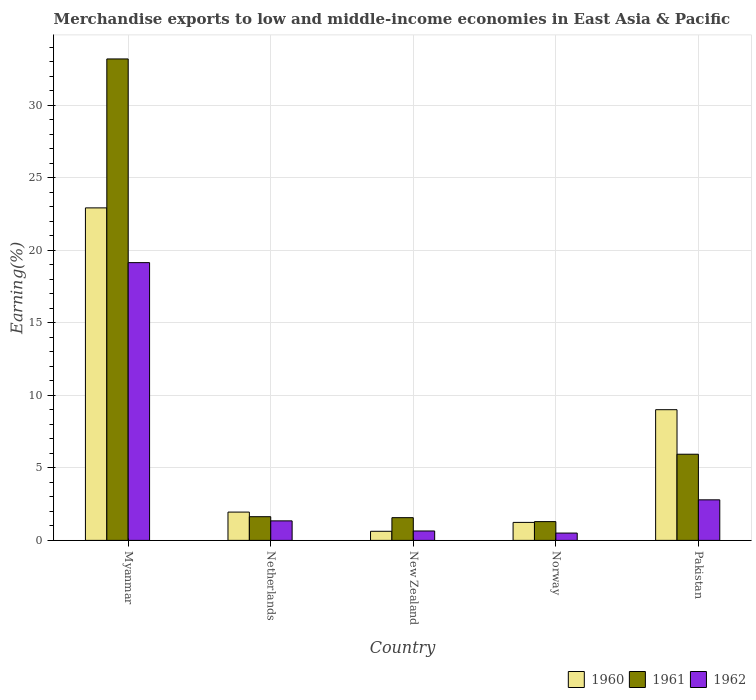How many groups of bars are there?
Ensure brevity in your answer.  5. Are the number of bars per tick equal to the number of legend labels?
Provide a succinct answer. Yes. Are the number of bars on each tick of the X-axis equal?
Offer a terse response. Yes. How many bars are there on the 4th tick from the left?
Your answer should be compact. 3. What is the label of the 2nd group of bars from the left?
Your answer should be very brief. Netherlands. In how many cases, is the number of bars for a given country not equal to the number of legend labels?
Offer a terse response. 0. What is the percentage of amount earned from merchandise exports in 1962 in New Zealand?
Offer a very short reply. 0.65. Across all countries, what is the maximum percentage of amount earned from merchandise exports in 1962?
Your answer should be compact. 19.15. Across all countries, what is the minimum percentage of amount earned from merchandise exports in 1962?
Provide a succinct answer. 0.5. In which country was the percentage of amount earned from merchandise exports in 1962 maximum?
Your response must be concise. Myanmar. In which country was the percentage of amount earned from merchandise exports in 1961 minimum?
Keep it short and to the point. Norway. What is the total percentage of amount earned from merchandise exports in 1962 in the graph?
Your answer should be very brief. 24.44. What is the difference between the percentage of amount earned from merchandise exports in 1960 in Myanmar and that in Pakistan?
Ensure brevity in your answer.  13.91. What is the difference between the percentage of amount earned from merchandise exports in 1962 in Myanmar and the percentage of amount earned from merchandise exports in 1960 in New Zealand?
Your answer should be very brief. 18.52. What is the average percentage of amount earned from merchandise exports in 1962 per country?
Keep it short and to the point. 4.89. What is the difference between the percentage of amount earned from merchandise exports of/in 1961 and percentage of amount earned from merchandise exports of/in 1960 in New Zealand?
Offer a terse response. 0.94. What is the ratio of the percentage of amount earned from merchandise exports in 1960 in New Zealand to that in Norway?
Provide a succinct answer. 0.51. Is the percentage of amount earned from merchandise exports in 1961 in Myanmar less than that in Pakistan?
Keep it short and to the point. No. Is the difference between the percentage of amount earned from merchandise exports in 1961 in Netherlands and New Zealand greater than the difference between the percentage of amount earned from merchandise exports in 1960 in Netherlands and New Zealand?
Your answer should be compact. No. What is the difference between the highest and the second highest percentage of amount earned from merchandise exports in 1961?
Your response must be concise. 27.25. What is the difference between the highest and the lowest percentage of amount earned from merchandise exports in 1962?
Your answer should be very brief. 18.64. Is the sum of the percentage of amount earned from merchandise exports in 1961 in Netherlands and Pakistan greater than the maximum percentage of amount earned from merchandise exports in 1962 across all countries?
Offer a very short reply. No. What does the 1st bar from the right in Pakistan represents?
Offer a very short reply. 1962. Is it the case that in every country, the sum of the percentage of amount earned from merchandise exports in 1961 and percentage of amount earned from merchandise exports in 1962 is greater than the percentage of amount earned from merchandise exports in 1960?
Make the answer very short. No. Are all the bars in the graph horizontal?
Give a very brief answer. No. Are the values on the major ticks of Y-axis written in scientific E-notation?
Give a very brief answer. No. Does the graph contain grids?
Offer a very short reply. Yes. How many legend labels are there?
Give a very brief answer. 3. How are the legend labels stacked?
Offer a very short reply. Horizontal. What is the title of the graph?
Provide a short and direct response. Merchandise exports to low and middle-income economies in East Asia & Pacific. What is the label or title of the Y-axis?
Make the answer very short. Earning(%). What is the Earning(%) of 1960 in Myanmar?
Your answer should be compact. 22.92. What is the Earning(%) in 1961 in Myanmar?
Offer a terse response. 33.19. What is the Earning(%) in 1962 in Myanmar?
Your response must be concise. 19.15. What is the Earning(%) in 1960 in Netherlands?
Keep it short and to the point. 1.95. What is the Earning(%) in 1961 in Netherlands?
Provide a short and direct response. 1.63. What is the Earning(%) of 1962 in Netherlands?
Give a very brief answer. 1.35. What is the Earning(%) in 1960 in New Zealand?
Provide a succinct answer. 0.63. What is the Earning(%) in 1961 in New Zealand?
Your response must be concise. 1.57. What is the Earning(%) in 1962 in New Zealand?
Ensure brevity in your answer.  0.65. What is the Earning(%) of 1960 in Norway?
Provide a short and direct response. 1.24. What is the Earning(%) in 1961 in Norway?
Your answer should be compact. 1.29. What is the Earning(%) in 1962 in Norway?
Offer a terse response. 0.5. What is the Earning(%) of 1960 in Pakistan?
Offer a terse response. 9.01. What is the Earning(%) in 1961 in Pakistan?
Your response must be concise. 5.94. What is the Earning(%) in 1962 in Pakistan?
Make the answer very short. 2.8. Across all countries, what is the maximum Earning(%) of 1960?
Your answer should be very brief. 22.92. Across all countries, what is the maximum Earning(%) in 1961?
Ensure brevity in your answer.  33.19. Across all countries, what is the maximum Earning(%) in 1962?
Provide a succinct answer. 19.15. Across all countries, what is the minimum Earning(%) of 1960?
Give a very brief answer. 0.63. Across all countries, what is the minimum Earning(%) in 1961?
Offer a terse response. 1.29. Across all countries, what is the minimum Earning(%) of 1962?
Ensure brevity in your answer.  0.5. What is the total Earning(%) in 1960 in the graph?
Your answer should be very brief. 35.75. What is the total Earning(%) of 1961 in the graph?
Provide a short and direct response. 43.63. What is the total Earning(%) of 1962 in the graph?
Your answer should be compact. 24.44. What is the difference between the Earning(%) in 1960 in Myanmar and that in Netherlands?
Keep it short and to the point. 20.97. What is the difference between the Earning(%) of 1961 in Myanmar and that in Netherlands?
Keep it short and to the point. 31.56. What is the difference between the Earning(%) in 1962 in Myanmar and that in Netherlands?
Provide a short and direct response. 17.8. What is the difference between the Earning(%) of 1960 in Myanmar and that in New Zealand?
Provide a succinct answer. 22.3. What is the difference between the Earning(%) in 1961 in Myanmar and that in New Zealand?
Provide a succinct answer. 31.62. What is the difference between the Earning(%) in 1962 in Myanmar and that in New Zealand?
Keep it short and to the point. 18.5. What is the difference between the Earning(%) in 1960 in Myanmar and that in Norway?
Offer a terse response. 21.68. What is the difference between the Earning(%) in 1961 in Myanmar and that in Norway?
Your answer should be compact. 31.9. What is the difference between the Earning(%) of 1962 in Myanmar and that in Norway?
Give a very brief answer. 18.64. What is the difference between the Earning(%) in 1960 in Myanmar and that in Pakistan?
Provide a succinct answer. 13.91. What is the difference between the Earning(%) of 1961 in Myanmar and that in Pakistan?
Keep it short and to the point. 27.25. What is the difference between the Earning(%) of 1962 in Myanmar and that in Pakistan?
Your answer should be compact. 16.35. What is the difference between the Earning(%) of 1960 in Netherlands and that in New Zealand?
Keep it short and to the point. 1.32. What is the difference between the Earning(%) in 1961 in Netherlands and that in New Zealand?
Provide a succinct answer. 0.07. What is the difference between the Earning(%) in 1962 in Netherlands and that in New Zealand?
Your response must be concise. 0.7. What is the difference between the Earning(%) in 1960 in Netherlands and that in Norway?
Your answer should be very brief. 0.71. What is the difference between the Earning(%) of 1961 in Netherlands and that in Norway?
Your answer should be very brief. 0.34. What is the difference between the Earning(%) in 1962 in Netherlands and that in Norway?
Give a very brief answer. 0.84. What is the difference between the Earning(%) of 1960 in Netherlands and that in Pakistan?
Offer a very short reply. -7.06. What is the difference between the Earning(%) of 1961 in Netherlands and that in Pakistan?
Keep it short and to the point. -4.31. What is the difference between the Earning(%) of 1962 in Netherlands and that in Pakistan?
Provide a short and direct response. -1.45. What is the difference between the Earning(%) in 1960 in New Zealand and that in Norway?
Give a very brief answer. -0.61. What is the difference between the Earning(%) in 1961 in New Zealand and that in Norway?
Your response must be concise. 0.27. What is the difference between the Earning(%) of 1962 in New Zealand and that in Norway?
Ensure brevity in your answer.  0.14. What is the difference between the Earning(%) in 1960 in New Zealand and that in Pakistan?
Provide a short and direct response. -8.38. What is the difference between the Earning(%) of 1961 in New Zealand and that in Pakistan?
Provide a succinct answer. -4.37. What is the difference between the Earning(%) of 1962 in New Zealand and that in Pakistan?
Make the answer very short. -2.15. What is the difference between the Earning(%) in 1960 in Norway and that in Pakistan?
Keep it short and to the point. -7.77. What is the difference between the Earning(%) of 1961 in Norway and that in Pakistan?
Provide a succinct answer. -4.65. What is the difference between the Earning(%) of 1962 in Norway and that in Pakistan?
Offer a terse response. -2.29. What is the difference between the Earning(%) in 1960 in Myanmar and the Earning(%) in 1961 in Netherlands?
Provide a short and direct response. 21.29. What is the difference between the Earning(%) of 1960 in Myanmar and the Earning(%) of 1962 in Netherlands?
Ensure brevity in your answer.  21.58. What is the difference between the Earning(%) in 1961 in Myanmar and the Earning(%) in 1962 in Netherlands?
Provide a succinct answer. 31.85. What is the difference between the Earning(%) in 1960 in Myanmar and the Earning(%) in 1961 in New Zealand?
Make the answer very short. 21.36. What is the difference between the Earning(%) in 1960 in Myanmar and the Earning(%) in 1962 in New Zealand?
Offer a very short reply. 22.27. What is the difference between the Earning(%) of 1961 in Myanmar and the Earning(%) of 1962 in New Zealand?
Offer a very short reply. 32.54. What is the difference between the Earning(%) in 1960 in Myanmar and the Earning(%) in 1961 in Norway?
Ensure brevity in your answer.  21.63. What is the difference between the Earning(%) of 1960 in Myanmar and the Earning(%) of 1962 in Norway?
Keep it short and to the point. 22.42. What is the difference between the Earning(%) in 1961 in Myanmar and the Earning(%) in 1962 in Norway?
Your answer should be very brief. 32.69. What is the difference between the Earning(%) of 1960 in Myanmar and the Earning(%) of 1961 in Pakistan?
Provide a short and direct response. 16.98. What is the difference between the Earning(%) of 1960 in Myanmar and the Earning(%) of 1962 in Pakistan?
Provide a short and direct response. 20.13. What is the difference between the Earning(%) in 1961 in Myanmar and the Earning(%) in 1962 in Pakistan?
Give a very brief answer. 30.39. What is the difference between the Earning(%) of 1960 in Netherlands and the Earning(%) of 1961 in New Zealand?
Ensure brevity in your answer.  0.39. What is the difference between the Earning(%) of 1960 in Netherlands and the Earning(%) of 1962 in New Zealand?
Provide a succinct answer. 1.3. What is the difference between the Earning(%) of 1961 in Netherlands and the Earning(%) of 1962 in New Zealand?
Keep it short and to the point. 0.98. What is the difference between the Earning(%) in 1960 in Netherlands and the Earning(%) in 1961 in Norway?
Your response must be concise. 0.66. What is the difference between the Earning(%) of 1960 in Netherlands and the Earning(%) of 1962 in Norway?
Offer a very short reply. 1.45. What is the difference between the Earning(%) in 1961 in Netherlands and the Earning(%) in 1962 in Norway?
Provide a succinct answer. 1.13. What is the difference between the Earning(%) of 1960 in Netherlands and the Earning(%) of 1961 in Pakistan?
Your answer should be very brief. -3.99. What is the difference between the Earning(%) in 1960 in Netherlands and the Earning(%) in 1962 in Pakistan?
Offer a terse response. -0.84. What is the difference between the Earning(%) of 1961 in Netherlands and the Earning(%) of 1962 in Pakistan?
Make the answer very short. -1.16. What is the difference between the Earning(%) of 1960 in New Zealand and the Earning(%) of 1961 in Norway?
Provide a short and direct response. -0.67. What is the difference between the Earning(%) in 1960 in New Zealand and the Earning(%) in 1962 in Norway?
Give a very brief answer. 0.12. What is the difference between the Earning(%) in 1961 in New Zealand and the Earning(%) in 1962 in Norway?
Provide a succinct answer. 1.06. What is the difference between the Earning(%) in 1960 in New Zealand and the Earning(%) in 1961 in Pakistan?
Offer a terse response. -5.31. What is the difference between the Earning(%) of 1960 in New Zealand and the Earning(%) of 1962 in Pakistan?
Keep it short and to the point. -2.17. What is the difference between the Earning(%) in 1961 in New Zealand and the Earning(%) in 1962 in Pakistan?
Ensure brevity in your answer.  -1.23. What is the difference between the Earning(%) in 1960 in Norway and the Earning(%) in 1962 in Pakistan?
Keep it short and to the point. -1.56. What is the difference between the Earning(%) in 1961 in Norway and the Earning(%) in 1962 in Pakistan?
Provide a succinct answer. -1.5. What is the average Earning(%) in 1960 per country?
Offer a terse response. 7.15. What is the average Earning(%) in 1961 per country?
Ensure brevity in your answer.  8.73. What is the average Earning(%) of 1962 per country?
Make the answer very short. 4.89. What is the difference between the Earning(%) in 1960 and Earning(%) in 1961 in Myanmar?
Your answer should be compact. -10.27. What is the difference between the Earning(%) in 1960 and Earning(%) in 1962 in Myanmar?
Make the answer very short. 3.78. What is the difference between the Earning(%) in 1961 and Earning(%) in 1962 in Myanmar?
Provide a short and direct response. 14.04. What is the difference between the Earning(%) in 1960 and Earning(%) in 1961 in Netherlands?
Make the answer very short. 0.32. What is the difference between the Earning(%) of 1960 and Earning(%) of 1962 in Netherlands?
Make the answer very short. 0.61. What is the difference between the Earning(%) of 1961 and Earning(%) of 1962 in Netherlands?
Provide a succinct answer. 0.29. What is the difference between the Earning(%) of 1960 and Earning(%) of 1961 in New Zealand?
Offer a very short reply. -0.94. What is the difference between the Earning(%) of 1960 and Earning(%) of 1962 in New Zealand?
Provide a short and direct response. -0.02. What is the difference between the Earning(%) in 1961 and Earning(%) in 1962 in New Zealand?
Provide a succinct answer. 0.92. What is the difference between the Earning(%) of 1960 and Earning(%) of 1961 in Norway?
Make the answer very short. -0.05. What is the difference between the Earning(%) of 1960 and Earning(%) of 1962 in Norway?
Make the answer very short. 0.74. What is the difference between the Earning(%) of 1961 and Earning(%) of 1962 in Norway?
Provide a succinct answer. 0.79. What is the difference between the Earning(%) in 1960 and Earning(%) in 1961 in Pakistan?
Ensure brevity in your answer.  3.07. What is the difference between the Earning(%) in 1960 and Earning(%) in 1962 in Pakistan?
Make the answer very short. 6.21. What is the difference between the Earning(%) in 1961 and Earning(%) in 1962 in Pakistan?
Offer a terse response. 3.14. What is the ratio of the Earning(%) of 1960 in Myanmar to that in Netherlands?
Offer a very short reply. 11.75. What is the ratio of the Earning(%) in 1961 in Myanmar to that in Netherlands?
Offer a very short reply. 20.31. What is the ratio of the Earning(%) in 1962 in Myanmar to that in Netherlands?
Make the answer very short. 14.23. What is the ratio of the Earning(%) in 1960 in Myanmar to that in New Zealand?
Ensure brevity in your answer.  36.54. What is the ratio of the Earning(%) of 1961 in Myanmar to that in New Zealand?
Offer a terse response. 21.19. What is the ratio of the Earning(%) in 1962 in Myanmar to that in New Zealand?
Make the answer very short. 29.51. What is the ratio of the Earning(%) of 1960 in Myanmar to that in Norway?
Provide a short and direct response. 18.48. What is the ratio of the Earning(%) in 1961 in Myanmar to that in Norway?
Your answer should be compact. 25.65. What is the ratio of the Earning(%) of 1962 in Myanmar to that in Norway?
Your answer should be compact. 37.92. What is the ratio of the Earning(%) of 1960 in Myanmar to that in Pakistan?
Your answer should be compact. 2.54. What is the ratio of the Earning(%) of 1961 in Myanmar to that in Pakistan?
Your answer should be very brief. 5.59. What is the ratio of the Earning(%) of 1962 in Myanmar to that in Pakistan?
Make the answer very short. 6.85. What is the ratio of the Earning(%) in 1960 in Netherlands to that in New Zealand?
Ensure brevity in your answer.  3.11. What is the ratio of the Earning(%) in 1961 in Netherlands to that in New Zealand?
Provide a succinct answer. 1.04. What is the ratio of the Earning(%) of 1962 in Netherlands to that in New Zealand?
Give a very brief answer. 2.07. What is the ratio of the Earning(%) of 1960 in Netherlands to that in Norway?
Give a very brief answer. 1.57. What is the ratio of the Earning(%) in 1961 in Netherlands to that in Norway?
Your answer should be compact. 1.26. What is the ratio of the Earning(%) of 1962 in Netherlands to that in Norway?
Provide a succinct answer. 2.67. What is the ratio of the Earning(%) in 1960 in Netherlands to that in Pakistan?
Offer a very short reply. 0.22. What is the ratio of the Earning(%) in 1961 in Netherlands to that in Pakistan?
Your response must be concise. 0.28. What is the ratio of the Earning(%) of 1962 in Netherlands to that in Pakistan?
Ensure brevity in your answer.  0.48. What is the ratio of the Earning(%) in 1960 in New Zealand to that in Norway?
Provide a succinct answer. 0.51. What is the ratio of the Earning(%) of 1961 in New Zealand to that in Norway?
Your answer should be very brief. 1.21. What is the ratio of the Earning(%) of 1962 in New Zealand to that in Norway?
Provide a succinct answer. 1.29. What is the ratio of the Earning(%) of 1960 in New Zealand to that in Pakistan?
Your answer should be very brief. 0.07. What is the ratio of the Earning(%) of 1961 in New Zealand to that in Pakistan?
Your answer should be compact. 0.26. What is the ratio of the Earning(%) in 1962 in New Zealand to that in Pakistan?
Your response must be concise. 0.23. What is the ratio of the Earning(%) in 1960 in Norway to that in Pakistan?
Provide a succinct answer. 0.14. What is the ratio of the Earning(%) of 1961 in Norway to that in Pakistan?
Offer a terse response. 0.22. What is the ratio of the Earning(%) of 1962 in Norway to that in Pakistan?
Provide a short and direct response. 0.18. What is the difference between the highest and the second highest Earning(%) in 1960?
Provide a short and direct response. 13.91. What is the difference between the highest and the second highest Earning(%) in 1961?
Provide a short and direct response. 27.25. What is the difference between the highest and the second highest Earning(%) in 1962?
Your answer should be compact. 16.35. What is the difference between the highest and the lowest Earning(%) of 1960?
Your response must be concise. 22.3. What is the difference between the highest and the lowest Earning(%) of 1961?
Keep it short and to the point. 31.9. What is the difference between the highest and the lowest Earning(%) in 1962?
Keep it short and to the point. 18.64. 